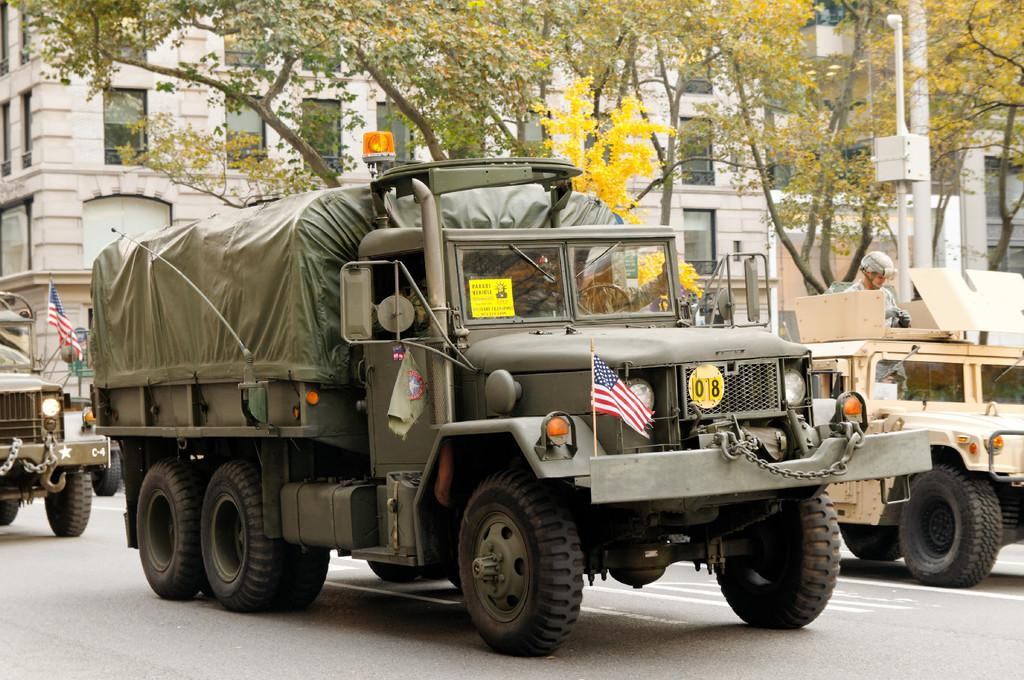What can be seen on the road in the image? There are vehicles on the road in the image. What else is visible in the image besides the vehicles? There are flags, a person, buildings, and trees visible in the image. Where are the buildings and trees located in the image? The buildings and trees are in the background of the image. How many cherries are being copied by the person in the image? There is no mention of cherries or copying in the image; the person is not interacting with any cherries. 